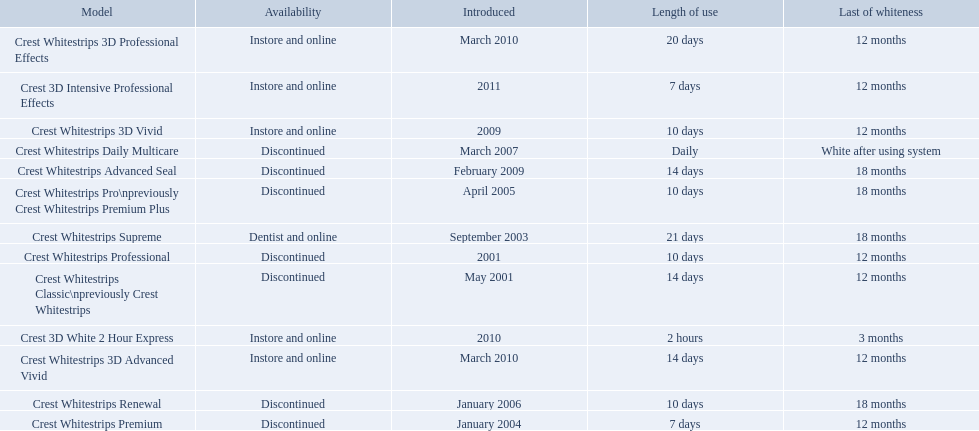What are all of the model names? Crest Whitestrips Classic\npreviously Crest Whitestrips, Crest Whitestrips Professional, Crest Whitestrips Supreme, Crest Whitestrips Premium, Crest Whitestrips Pro\npreviously Crest Whitestrips Premium Plus, Crest Whitestrips Renewal, Crest Whitestrips Daily Multicare, Crest Whitestrips Advanced Seal, Crest Whitestrips 3D Vivid, Crest Whitestrips 3D Advanced Vivid, Crest Whitestrips 3D Professional Effects, Crest 3D White 2 Hour Express, Crest 3D Intensive Professional Effects. When were they first introduced? May 2001, 2001, September 2003, January 2004, April 2005, January 2006, March 2007, February 2009, 2009, March 2010, March 2010, 2010, 2011. Along with crest whitestrips 3d advanced vivid, which other model was introduced in march 2010? Crest Whitestrips 3D Professional Effects. When was crest whitestrips 3d advanced vivid introduced? March 2010. What other product was introduced in march 2010? Crest Whitestrips 3D Professional Effects. 